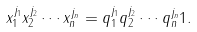Convert formula to latex. <formula><loc_0><loc_0><loc_500><loc_500>x _ { 1 } ^ { j _ { 1 } } x _ { 2 } ^ { j _ { 2 } } \cdots x _ { n } ^ { j _ { n } } = q _ { 1 } ^ { j _ { 1 } } q _ { 2 } ^ { j _ { 2 } } \cdots q _ { n } ^ { j _ { n } } 1 .</formula> 